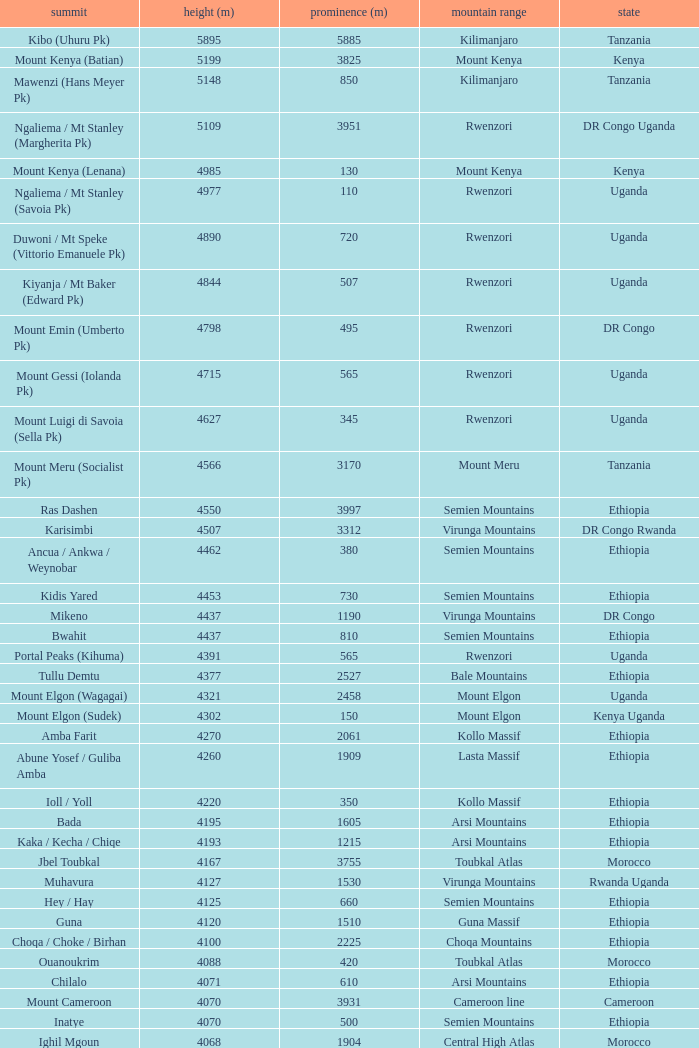How tall is the Mountain of jbel ghat? 1.0. 